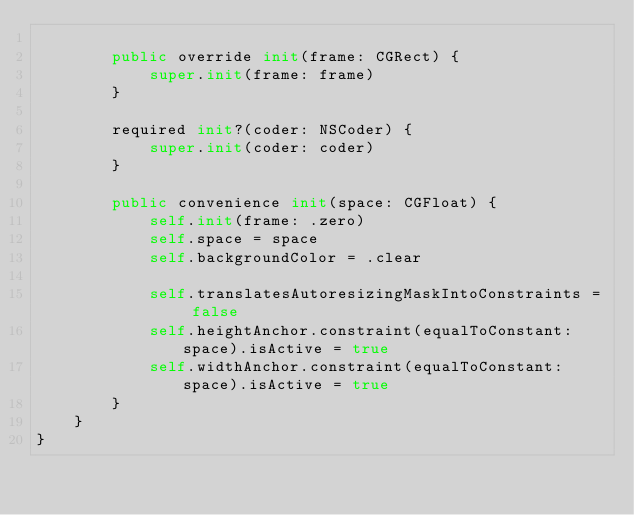Convert code to text. <code><loc_0><loc_0><loc_500><loc_500><_Swift_>
        public override init(frame: CGRect) {
            super.init(frame: frame)
        }

        required init?(coder: NSCoder) {
            super.init(coder: coder)
        }

        public convenience init(space: CGFloat) {
            self.init(frame: .zero)
            self.space = space
            self.backgroundColor = .clear

            self.translatesAutoresizingMaskIntoConstraints = false
            self.heightAnchor.constraint(equalToConstant: space).isActive = true
            self.widthAnchor.constraint(equalToConstant: space).isActive = true
        }
    }
}
</code> 